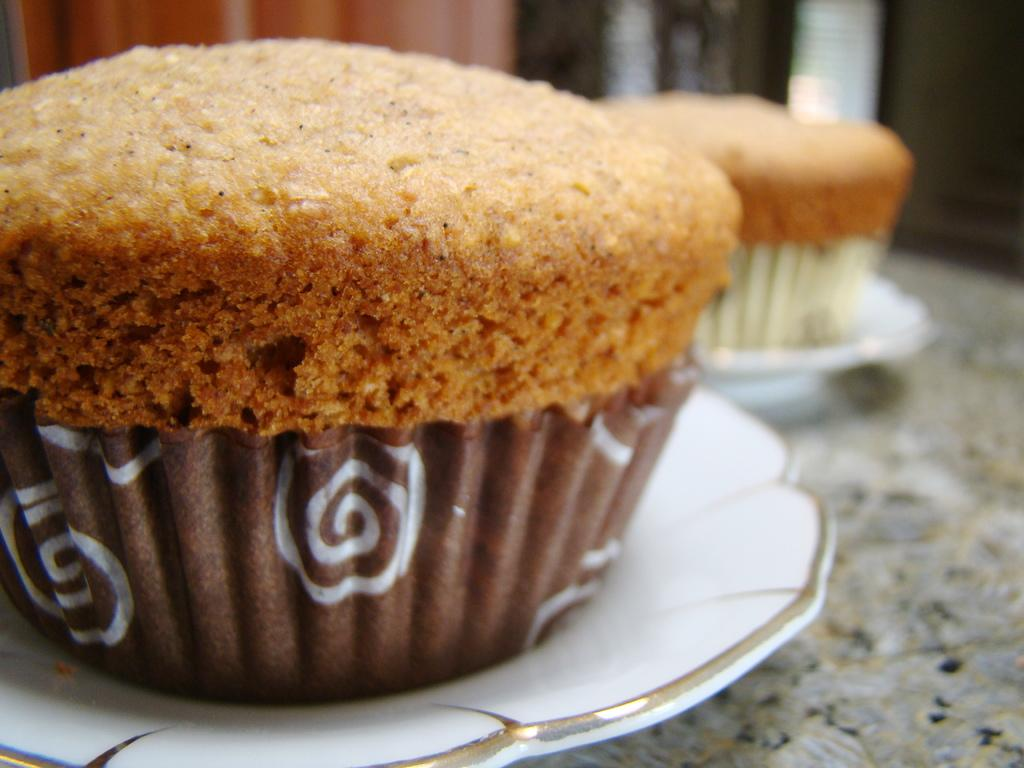How many cupcakes are visible in the image? There are two cupcakes in the image. What color are the plates on which the cupcakes are placed? The plates are white in color. What is the color of the cupcakes? The cupcakes are brown in color. Where are the plates with the cupcakes located? The plates with the cupcakes are placed on a table. Can you describe the background of the image? The background of the image is blurred. What type of scarf is draped over the cupcakes in the image? There is no scarf present in the image; it only features two cupcakes on white plates. How long did the owner of the cupcakes rest before taking the picture? There is no information about an owner or the time before taking the picture, so it cannot be determined. 